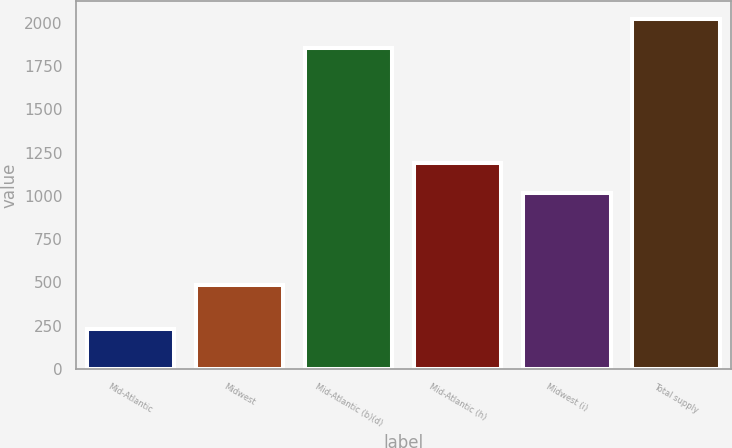<chart> <loc_0><loc_0><loc_500><loc_500><bar_chart><fcel>Mid-Atlantic<fcel>Midwest<fcel>Mid-Atlantic (b)(d)<fcel>Mid-Atlantic (h)<fcel>Midwest (i)<fcel>Total supply<nl><fcel>230<fcel>483<fcel>1854<fcel>1188.6<fcel>1017<fcel>2025.6<nl></chart> 